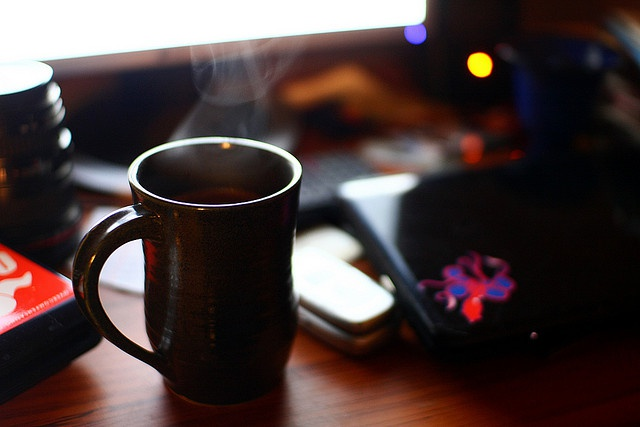Describe the objects in this image and their specific colors. I can see laptop in white, black, maroon, and gray tones, cup in white, black, lavender, maroon, and darkgray tones, and cell phone in white, black, maroon, and gray tones in this image. 